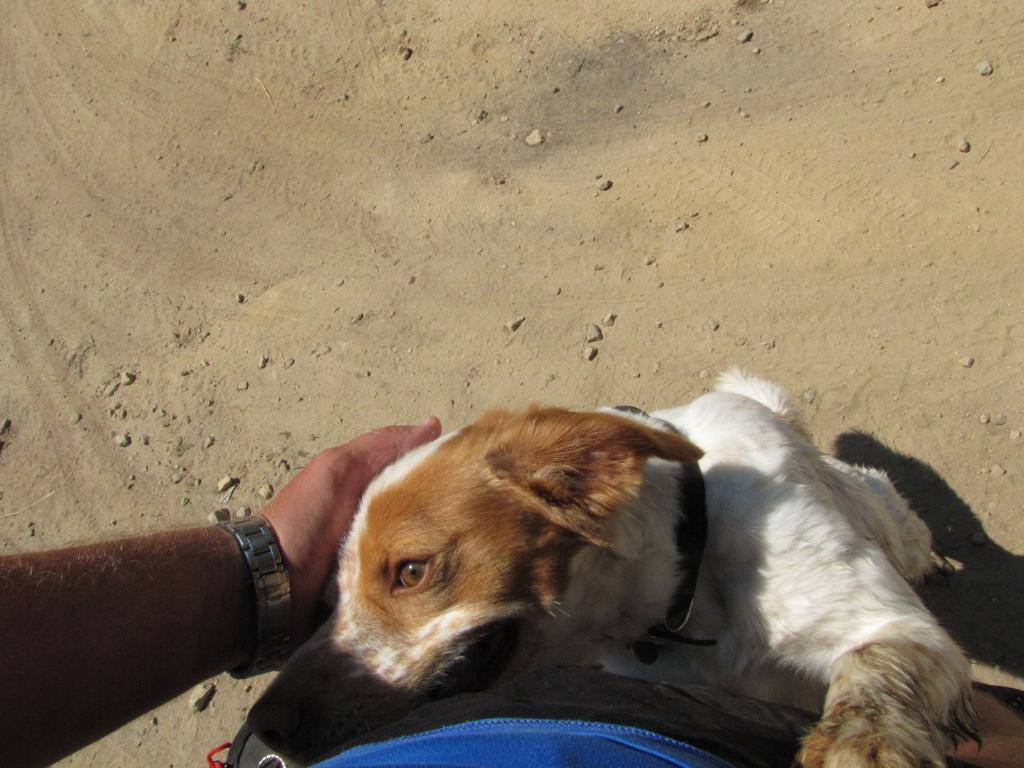What is present in the image? There is a person and a dog in the image. What is the person wearing on their wrist? The person is wearing a wrist watch. Can you describe the position of the dog in the image? The dog is on the ground in the image. How many people are in the crowd depicted in the image? There is no crowd present in the image; it only features a person and a dog. What type of pail is being used by the person in the image? There is no pail present in the image. 